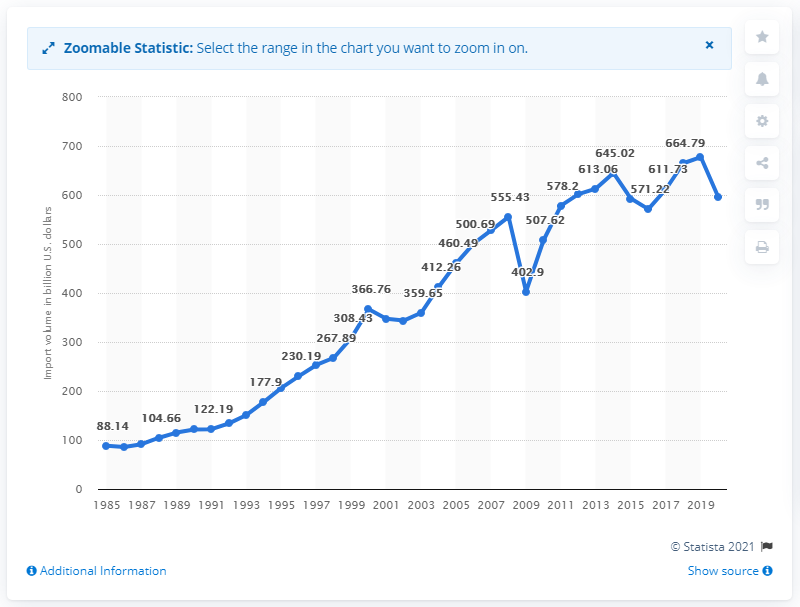List a handful of essential elements in this visual. In 2020, the value of U.S. imports from North America was 595.78 billion dollars. 